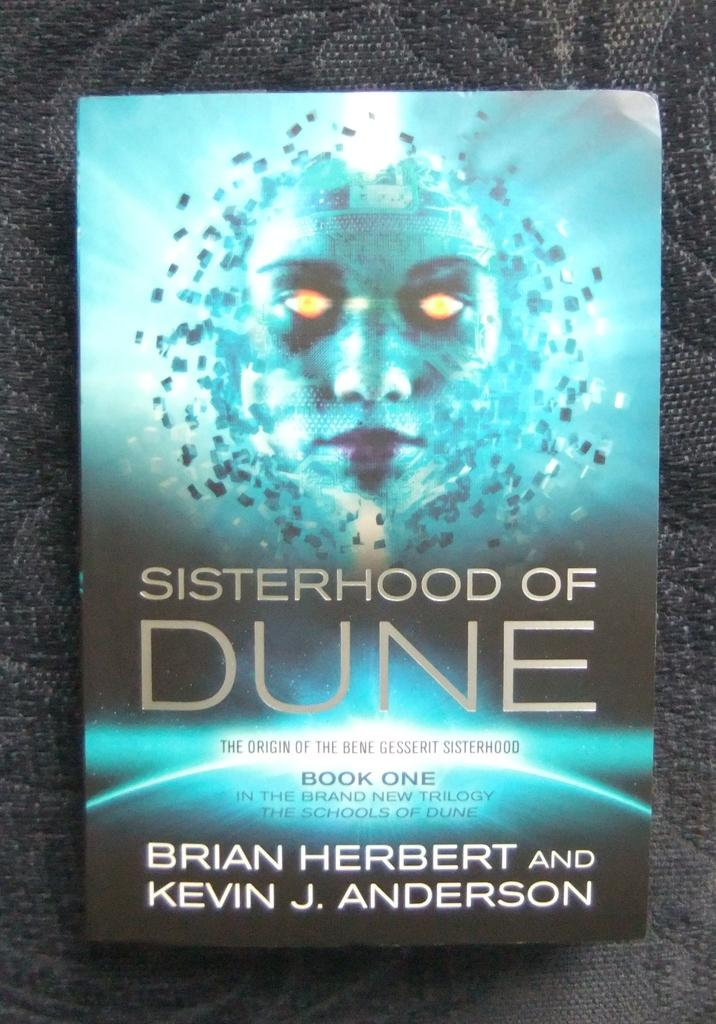<image>
Present a compact description of the photo's key features. A book cover for Sisterhood of Dune features a face with glowing yellow eyes. 